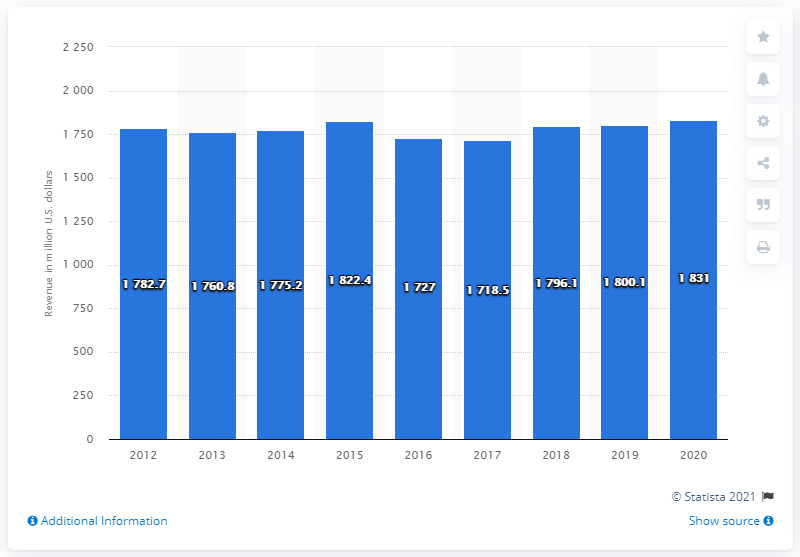Draw attention to some important aspects in this diagram. A report was released in 2020 on the global revenue of John Wiley & Sons Inc. In the last fiscal year of John Wiley & Sons, which was 1831, the company's annual revenue was $1831. 